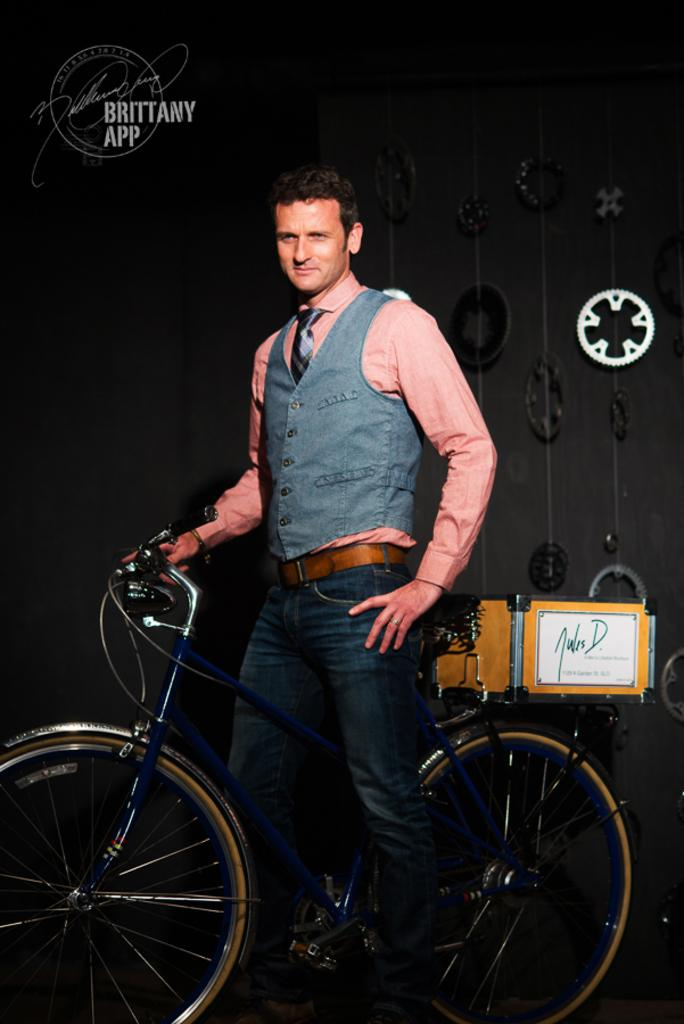What is the main subject of the image? There is a man in the image. What is the man doing in the image? The man is on a bicycle. What object can be seen in the image besides the man and the bicycle? There is a box in the image. What can be seen in the background of the image? There is a wall in the background of the image. What part of the bicycle is visible in the image? There is a wheel in the image. How many snails are crawling on the man's shoulder in the image? There are no snails present in the image; the man is riding a bicycle with a wheel and a box nearby. 